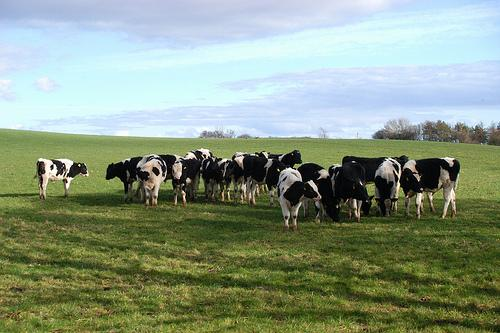Provide a brief summary of the overall scene in the image using varied phrases. In a tranquil field with green, lush grass and scattered shadows, a few black and white cows are captured munching their way through the area, with trees and the blue expanse of the sky in the background. What are the main subjects in the image, and what is happening in the scene? The main subjects are the cows that are grazing on a field, with tree shadows, trees, and sky as parts of their surroundings. Describe the setting and scenery where the cows are grazing. The cows are grazing in a wide-open field with green grass, tree shadows, and a clear blue sky with clouds and trees in the background. Mention the primary elements present in the image, including the animals and their surroundings. There is a herd of black and white cows grazing on a large area of green grass with tree shadows on the ground, and trees and blue sky in the background. How could one describe the cows' actions and their surroundings using adjectives? Several black and white cows peacefully graze on a vast, green grass-covered field, under a clear, blue sky with trees in the distance. In one sentence, provide a brief overview of the scene captured in the image. The image shows a group of cows grazing on a sunny day in a field with trees and blue sky in the distance. Describe the overall setting and atmosphere of the image. The image has a calm and peaceful atmosphere with cows grazing on a green field, trees in the distance, and a blue sky with white clouds. Mention the colors and key elements present in the image. Colors in the image include black and white cows, green grass, tree shadows, blue sky, white clouds, and gray shadows on the grass. Share some distinctive characteristics about the cows and their environment. Some cows have black spots, black heads, and tags on their ears, while their environment has green grass, trees, and shadows on the ground. What color are the cows and what activity are they engaged in? The cows are black and white and they are engaged in grazing on the grass. 